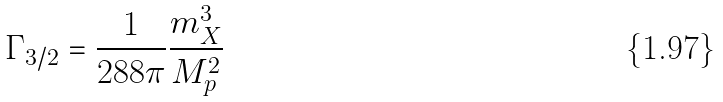<formula> <loc_0><loc_0><loc_500><loc_500>\Gamma _ { 3 / 2 } = \frac { 1 } { 2 8 8 \pi } \frac { m _ { X } ^ { 3 } } { M _ { p } ^ { 2 } }</formula> 